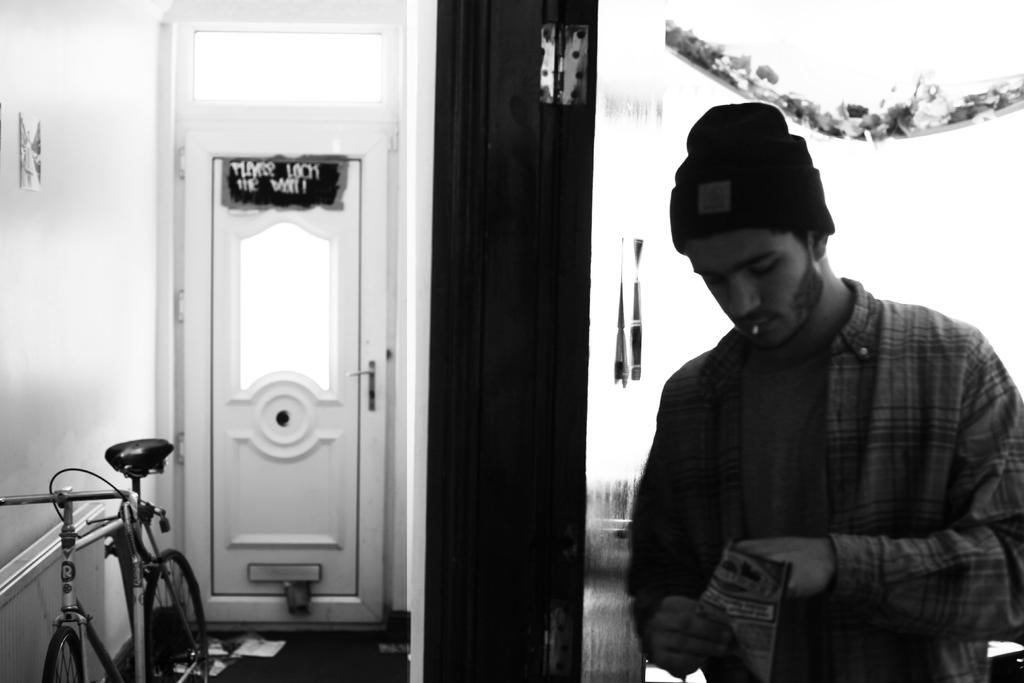Who or what is present in the image? There is a person in the image. What is the person holding? The person is holding a packet. What type of structure can be seen in the image? There is a door and a wall in the image. Is there any mode of transportation visible in the image? Yes, there is a bicycle in the image. Is there any blood visible on the person or the bicycle in the image? No, there is no blood visible on the person or the bicycle in the image. 